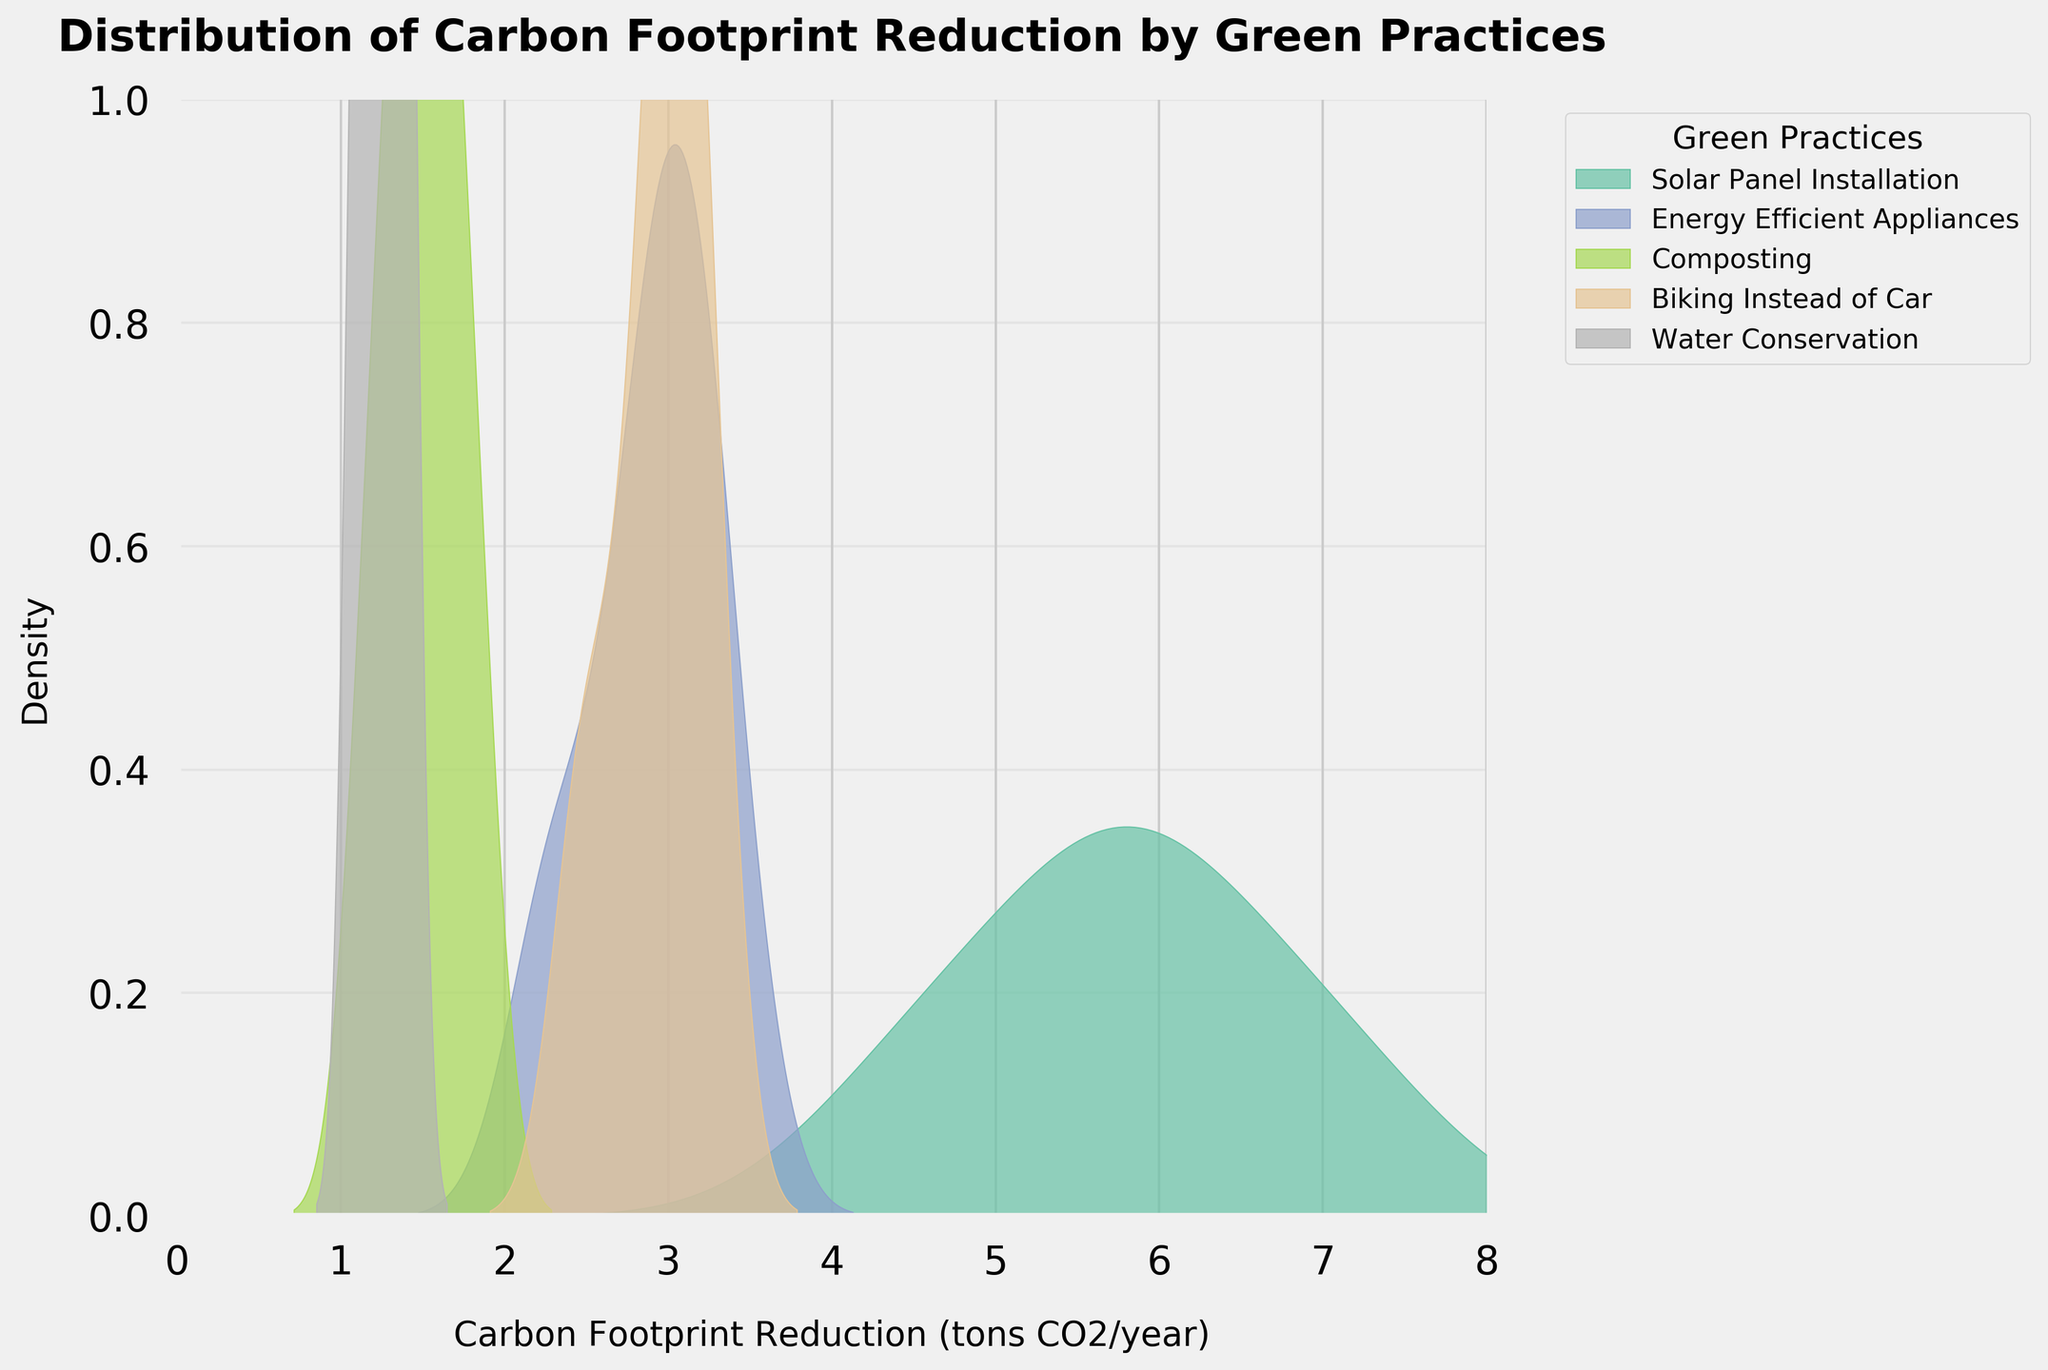What is the title of the figure? The title is typically displayed at the top of the figure. In this case, it should be clearly in large, bold font. It states the main purpose or theme of the plot.
Answer: Distribution of Carbon Footprint Reduction by Green Practices Which green practice shows the highest carbon footprint reduction density peak? Look at the highest point of each density curve in the figure and compare them. The curve with the highest peak represents the practice with the highest reduction density.
Answer: Solar Panel Installation What value range of carbon footprint reduction is covered by 'Composting'? Identify the x-axis range over which the density curve of 'Composting' extends. This curve should start and end at specified points on the x-axis.
Answer: 1.2 to 1.8 tons CO2/year Between 'Biking Instead of Car' and 'Energy Efficient Appliances', which practice shows a higher peak density? Compare the maximum height (peak) of the density curves for 'Biking Instead of Car' and 'Energy Efficient Appliances'. The curve with the higher peak denotes the higher peak density.
Answer: Biking Instead of Car What is the approximate carbon footprint reduction for the peak density of 'Water Conservation'? Locate the highest point on the density curve for 'Water Conservation' and then trace downward to the corresponding value on the x-axis, which represents carbon footprint reduction.
Answer: Approximately 1.3 tons CO2/year Which green practice has the narrowest range of carbon footprint reduction? Find the density curve with the shortest span along the x-axis, indicating the narrowest range.
Answer: Water Conservation Is there any overlap in the carbon footprint reduction ranges of 'Solar Panel Installation' and 'Energy Efficient Appliances'? Check both density curves and see if they spread across any common x-axis values. If both curves are above the x-axis in a common range, there is an overlap.
Answer: Yes What practice shows a density peak around 1.5 tons CO2/year? Look for a density curve that reaches its maximum or peak value around the 1.5 mark on the x-axis.
Answer: Composting Between 'Solar Panel Installation' and 'Composting', which practice generally achieves greater carbon footprint reduction? Compare the x-axis values of the peaks and the overall spread of the density curves for both practices. The practice with higher x-axis values corresponds to a greater reduction.
Answer: Solar Panel Installation Which green practice has the most extended range of carbon footprint reduction? Identify the density curve that stretches the furthest along the x-axis, indicating the most extensive range of reductions.
Answer: Solar Panel Installation 